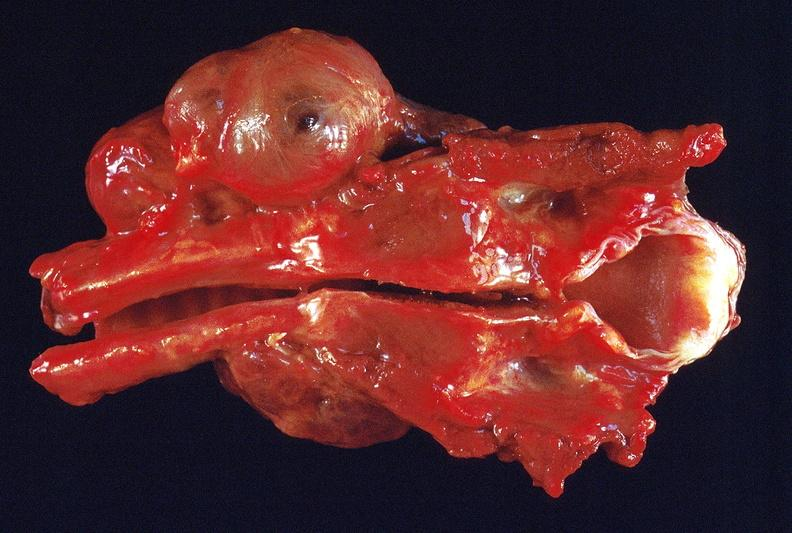does lymphangiomatosis show thyroid, goiter?
Answer the question using a single word or phrase. No 